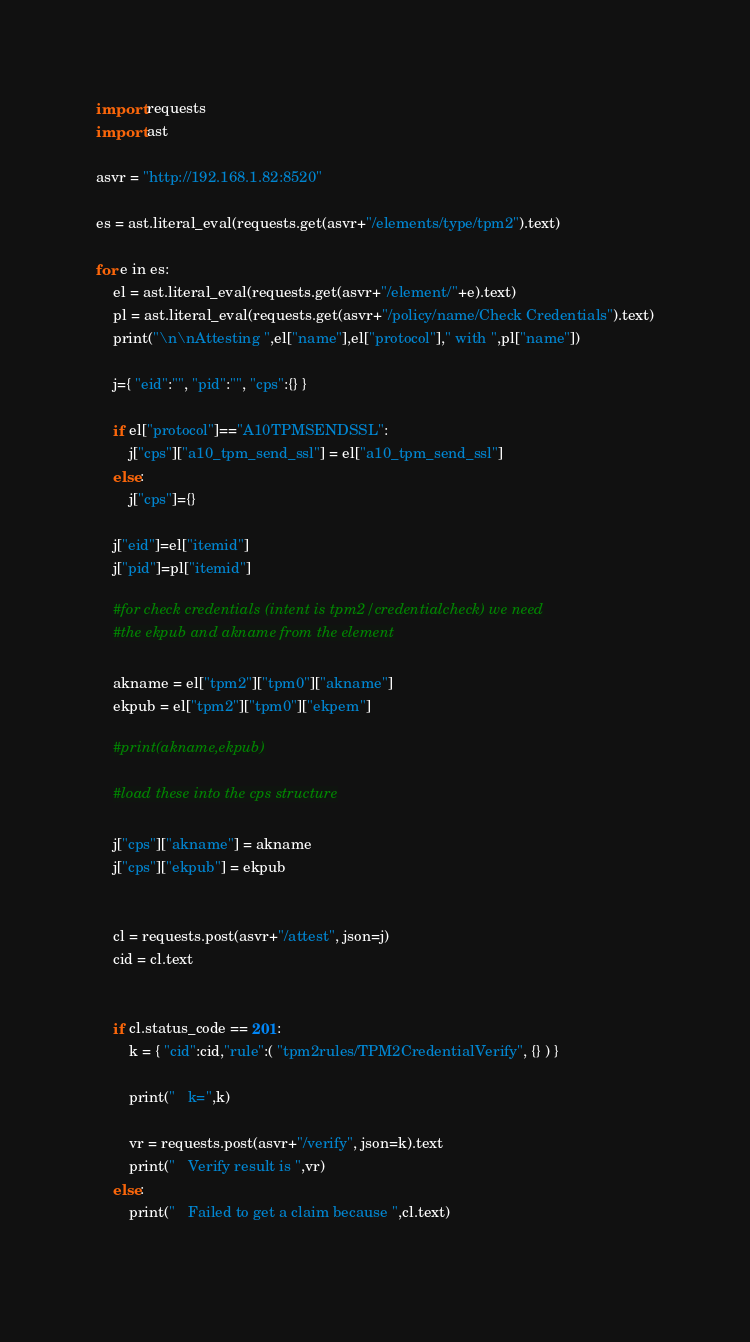<code> <loc_0><loc_0><loc_500><loc_500><_Python_>import requests
import ast

asvr = "http://192.168.1.82:8520"

es = ast.literal_eval(requests.get(asvr+"/elements/type/tpm2").text)

for e in es:
    el = ast.literal_eval(requests.get(asvr+"/element/"+e).text)
    pl = ast.literal_eval(requests.get(asvr+"/policy/name/Check Credentials").text)
    print("\n\nAttesting ",el["name"],el["protocol"]," with ",pl["name"])

    j={ "eid":"", "pid":"", "cps":{} }

    if el["protocol"]=="A10TPMSENDSSL":
        j["cps"]["a10_tpm_send_ssl"] = el["a10_tpm_send_ssl"]
    else:
        j["cps"]={}

    j["eid"]=el["itemid"]
    j["pid"]=pl["itemid"]
      
    #for check credentials (intent is tpm2/credentialcheck) we need
    #the ekpub and akname from the element

    akname = el["tpm2"]["tpm0"]["akname"]
    ekpub = el["tpm2"]["tpm0"]["ekpem"]

    #print(akname,ekpub)

    #load these into the cps structure

    j["cps"]["akname"] = akname
    j["cps"]["ekpub"] = ekpub


    cl = requests.post(asvr+"/attest", json=j)
    cid = cl.text


    if cl.status_code == 201:
        k = { "cid":cid,"rule":( "tpm2rules/TPM2CredentialVerify", {} ) }

        print("   k=",k)

        vr = requests.post(asvr+"/verify", json=k).text
        print("   Verify result is ",vr)
    else:
        print("   Failed to get a claim because ",cl.text)
        
</code> 